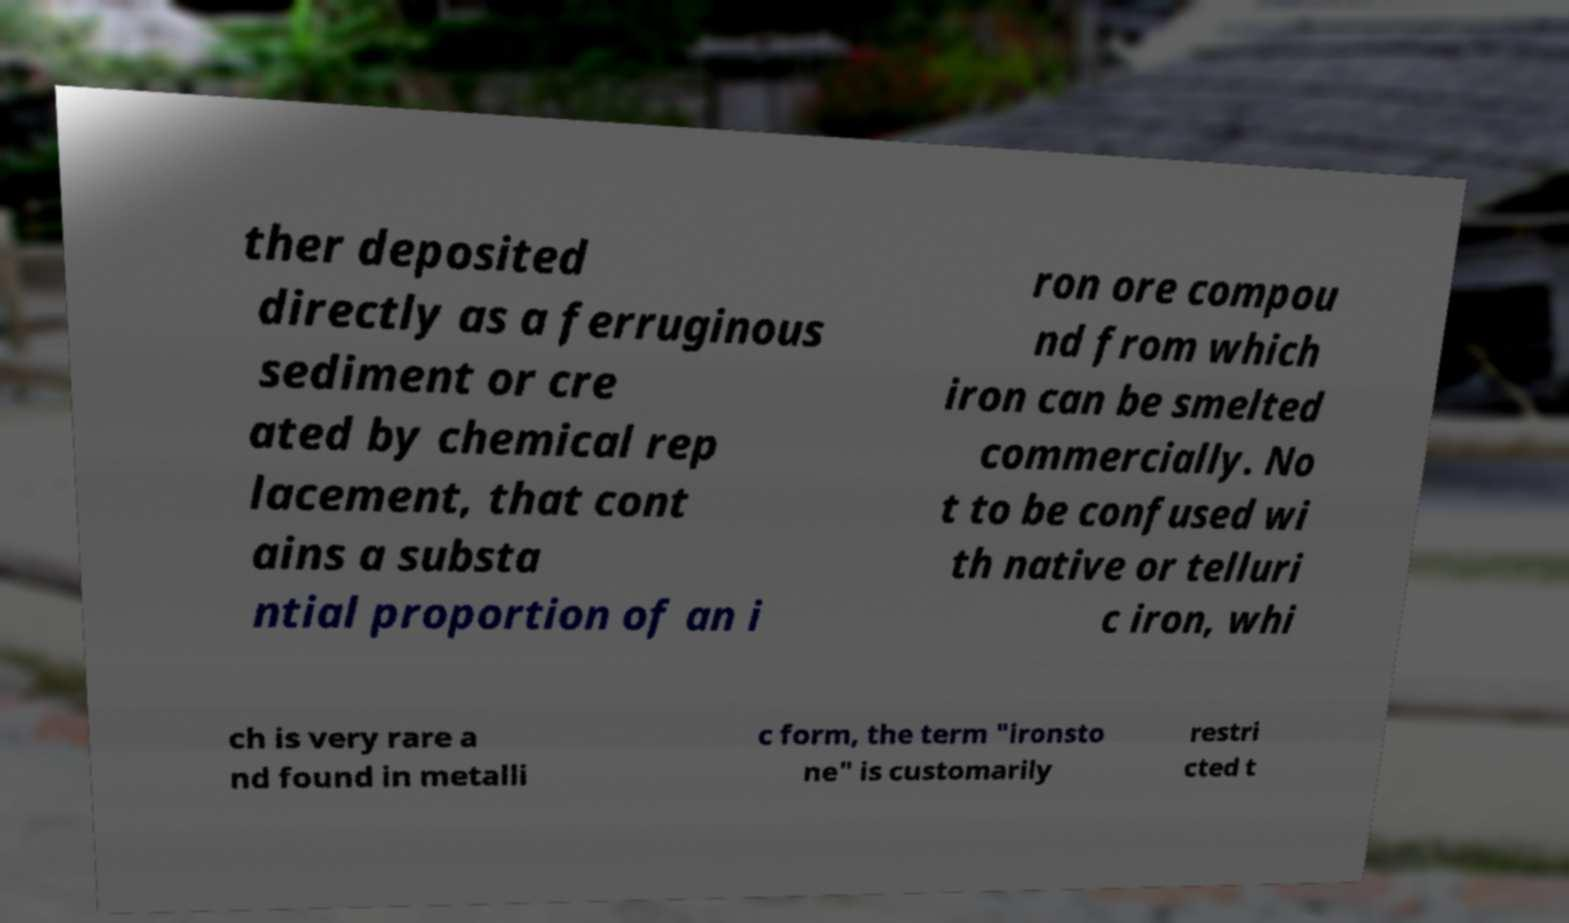Can you read and provide the text displayed in the image?This photo seems to have some interesting text. Can you extract and type it out for me? ther deposited directly as a ferruginous sediment or cre ated by chemical rep lacement, that cont ains a substa ntial proportion of an i ron ore compou nd from which iron can be smelted commercially. No t to be confused wi th native or telluri c iron, whi ch is very rare a nd found in metalli c form, the term "ironsto ne" is customarily restri cted t 